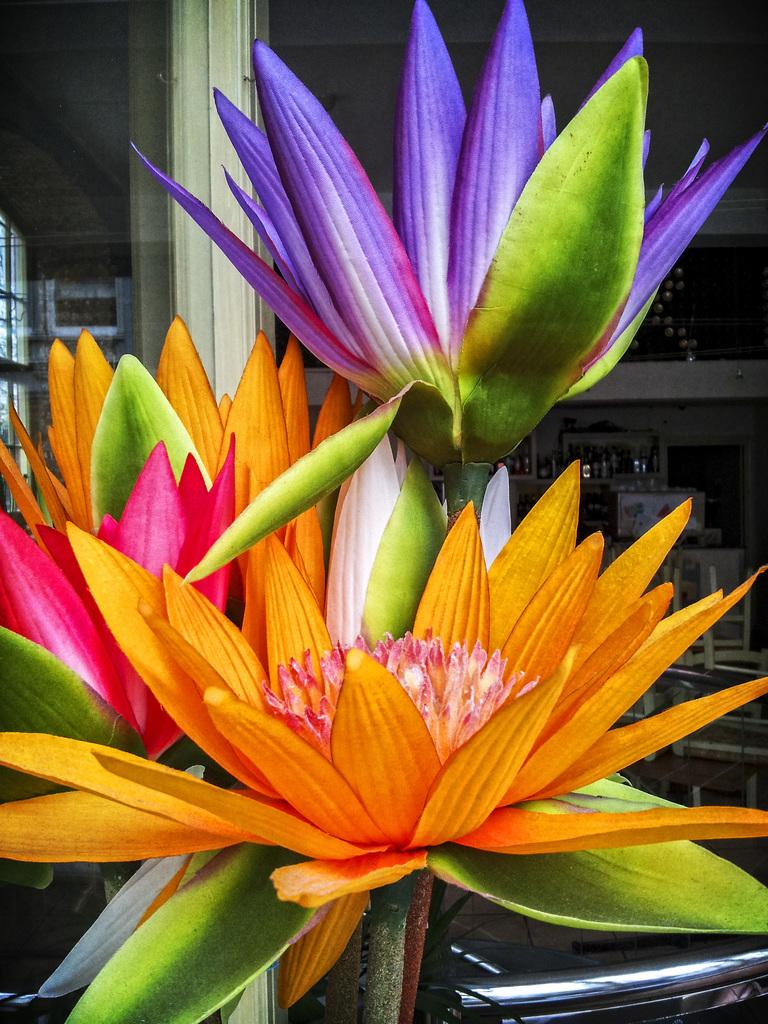What is the main subject of the image? There is a bunch of flowers in the image. What can be seen in the background of the image? There is a metal pole, chairs, objects placed on a surface, and a window in the background of the image. What type of pie is being served on the train in the image? There is no pie or train present in the image; it features a bunch of flowers and objects in the background. 